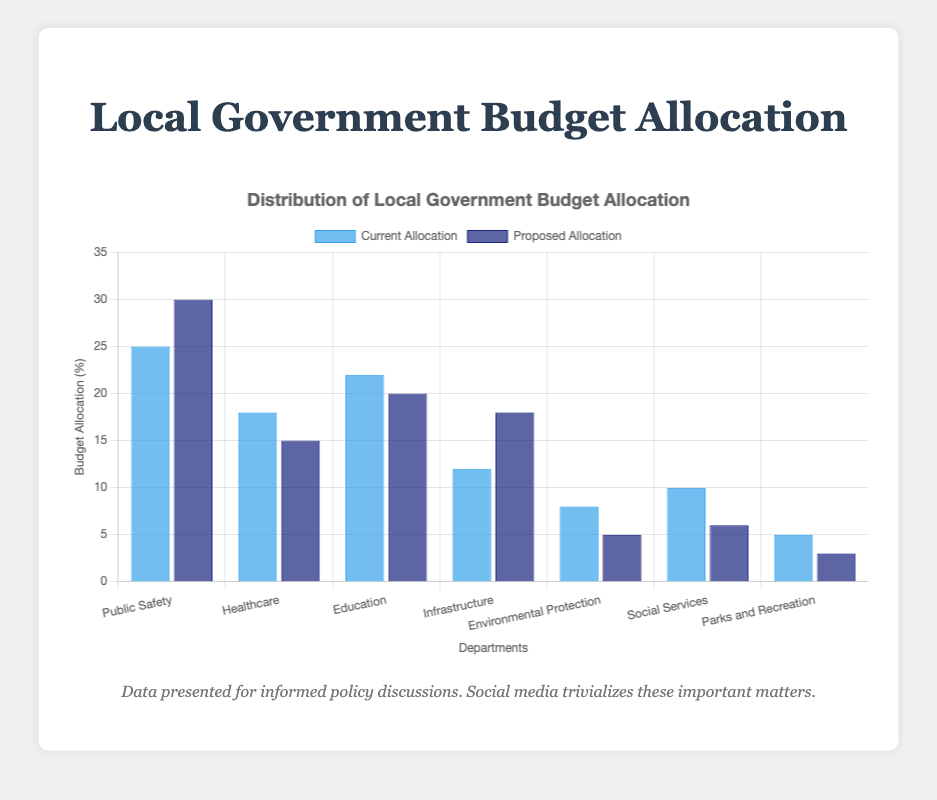Which department has the highest current allocation? The highest current allocation is indicated by the tallest blue bar. Reviewing the chart, the blue bar for "Public Safety" is the highest with a value of 25%.
Answer: Public Safety Which department's allocation increased the most in the proposed allocation? To find the department with the highest increase, calculate the difference between the proposed (dark blue) and current (blue) allocations for each department. The difference can be seen visually and numerically on the chart. For "Infrastructure," the increase is from 12% to 18%, which is 6%, the largest increase among all departments.
Answer: Infrastructure What is the total current allocation for Healthcare and Education combined? Add the current allocation percentages for Healthcare and Education. From the chart, these are 18% and 22%, respectively. Thus, 18% + 22% = 40%.
Answer: 40% Which department has the same value for both current and proposed allocations? By examining the height of the blue and dark blue bars, you can see that the bars for "Parks and Recreation" are closest but not equal. All others have different current and proposed allocations.
Answer: None What is the average proposed allocation across all departments? Add all the proposed allocation percentages and divide by the number of departments. (30 + 15 + 20 + 18 + 5 + 6 + 3) / 7 = 97 / 7 ≈ 13.86%.
Answer: 13.86% Which department saw a decrease in its proposed allocation compared to its current allocation? Look for bars where the proposed (dark blue) allocation is less than the current (blue) allocation. Public Safety has an increase from 25% to 30%, and so on. Comparing these for "Healthcare" (from 18% to 15%), "Environmental Protection" (from 8% to 5%), "Social Services" (from 10% to 6%), and "Parks and Recreation" (from 5% to 3%), we see that these departments saw a decrease.
Answer: Healthcare, Environmental Protection, Social Services, Parks and Recreation Which department has the smallest proposed allocation? The smallest proposed allocation is indicated by the shortest dark blue bar. Visually checking, the bar for "Parks and Recreation" is the shortest at 3%.
Answer: Parks and Recreation How much more is allocated to Education in the current budget compared to Environmental Protection in the proposed budget? Subtract the proposed allocation for Environmental Protection from the current allocation for Education. From the chart: 22% (Education current) - 5% (Environmental Protection proposed) = 17%.
Answer: 17% What is the difference between the current and proposed allocation for Social Services? Subtract the current allocation from the proposed allocation for Social Services. From the chart: 6% (Social Services proposed) - 10% (Social Services current) = -4% (a decrease).
Answer: -4% Which two departments have the closest current allocation percentages? Compare the current allocation percentages visually and find bars of almost equal height. The closest values are "Infrastructure" (12%) and "Social Services" (10%), with a difference of just 2%.
Answer: Infrastructure and Social Services 